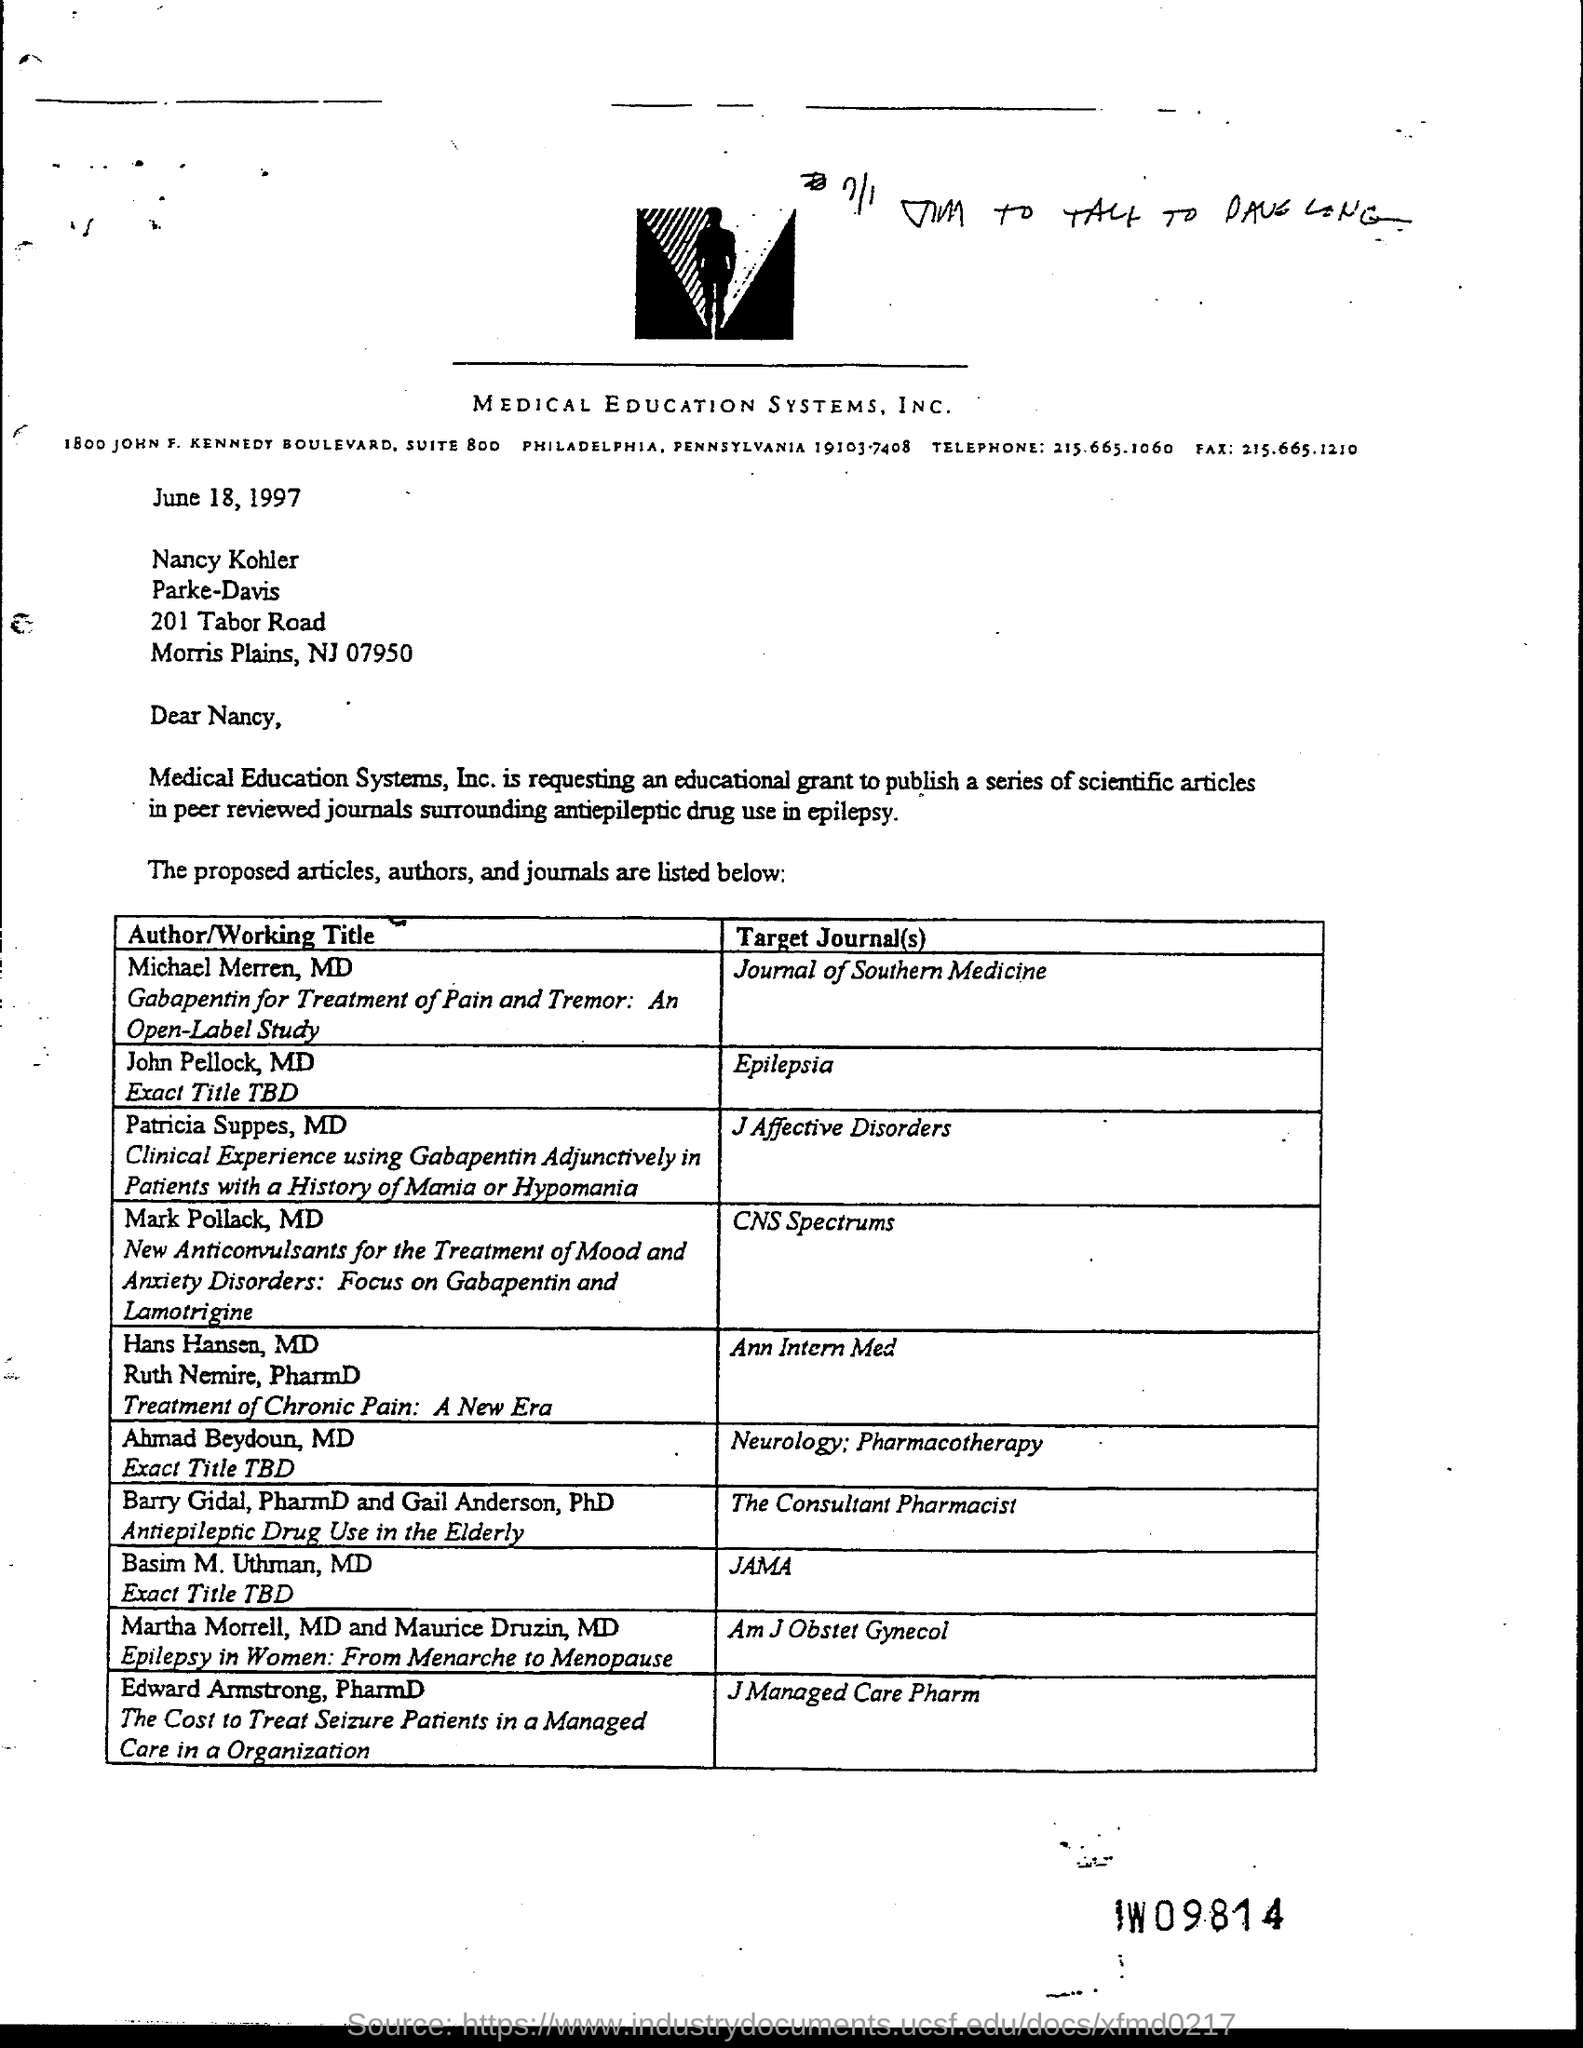Point out several critical features in this image. The article titled "Gabapentin for Treatment of Pain and Tremor: An Open-Label Study" was written by Dr. Michael Merren, MD. The date mentioned in this letter is June 18, 1997. The letter's heading mentions Medical Education Systems, Inc., a company. 